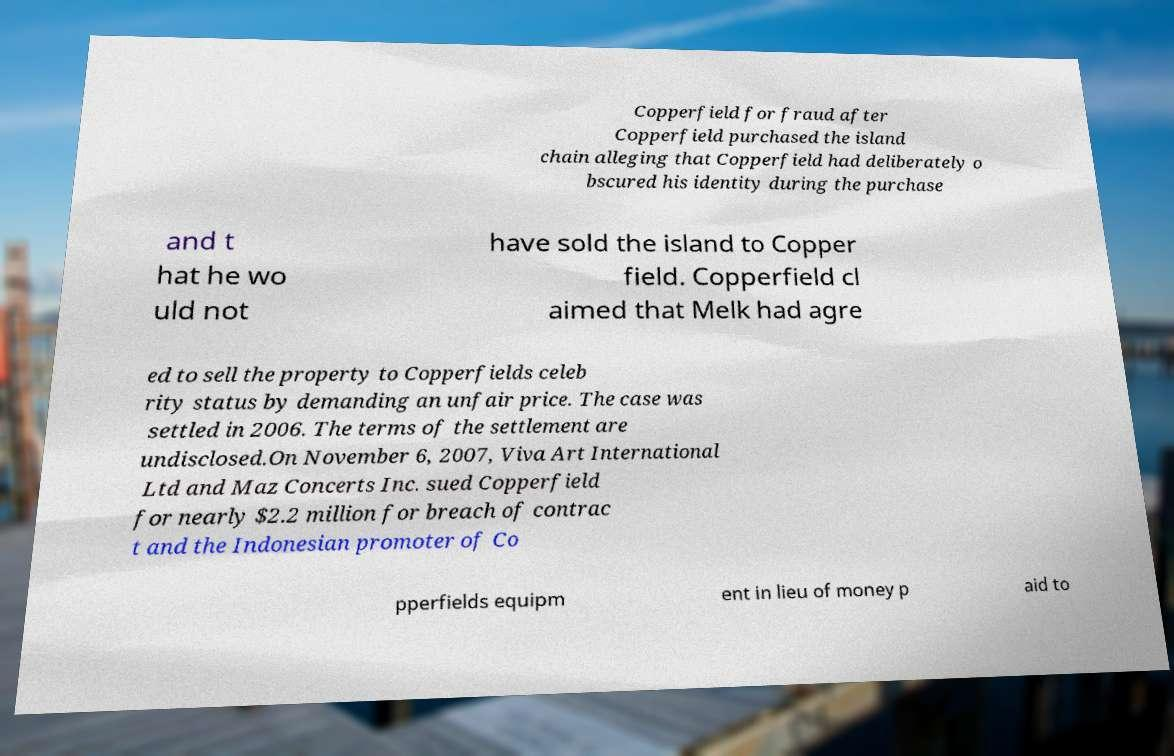For documentation purposes, I need the text within this image transcribed. Could you provide that? Copperfield for fraud after Copperfield purchased the island chain alleging that Copperfield had deliberately o bscured his identity during the purchase and t hat he wo uld not have sold the island to Copper field. Copperfield cl aimed that Melk had agre ed to sell the property to Copperfields celeb rity status by demanding an unfair price. The case was settled in 2006. The terms of the settlement are undisclosed.On November 6, 2007, Viva Art International Ltd and Maz Concerts Inc. sued Copperfield for nearly $2.2 million for breach of contrac t and the Indonesian promoter of Co pperfields equipm ent in lieu of money p aid to 